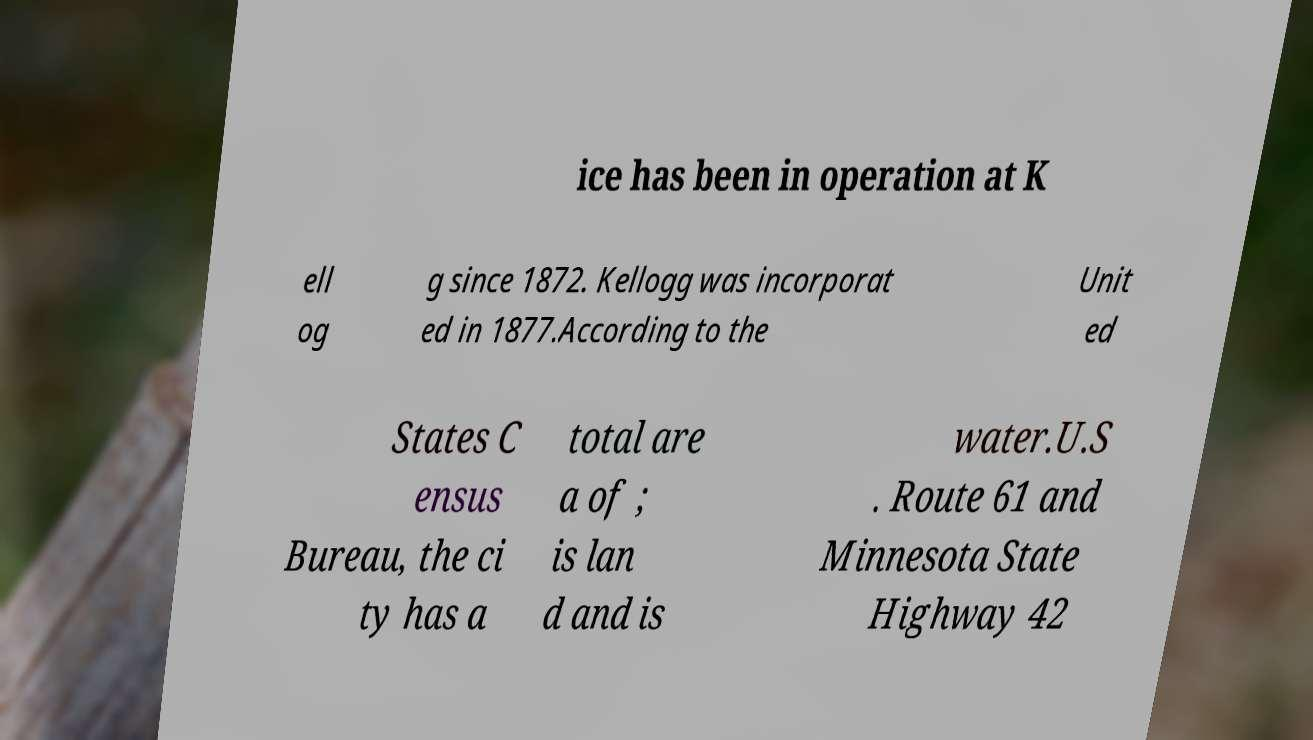What messages or text are displayed in this image? I need them in a readable, typed format. ice has been in operation at K ell og g since 1872. Kellogg was incorporat ed in 1877.According to the Unit ed States C ensus Bureau, the ci ty has a total are a of ; is lan d and is water.U.S . Route 61 and Minnesota State Highway 42 